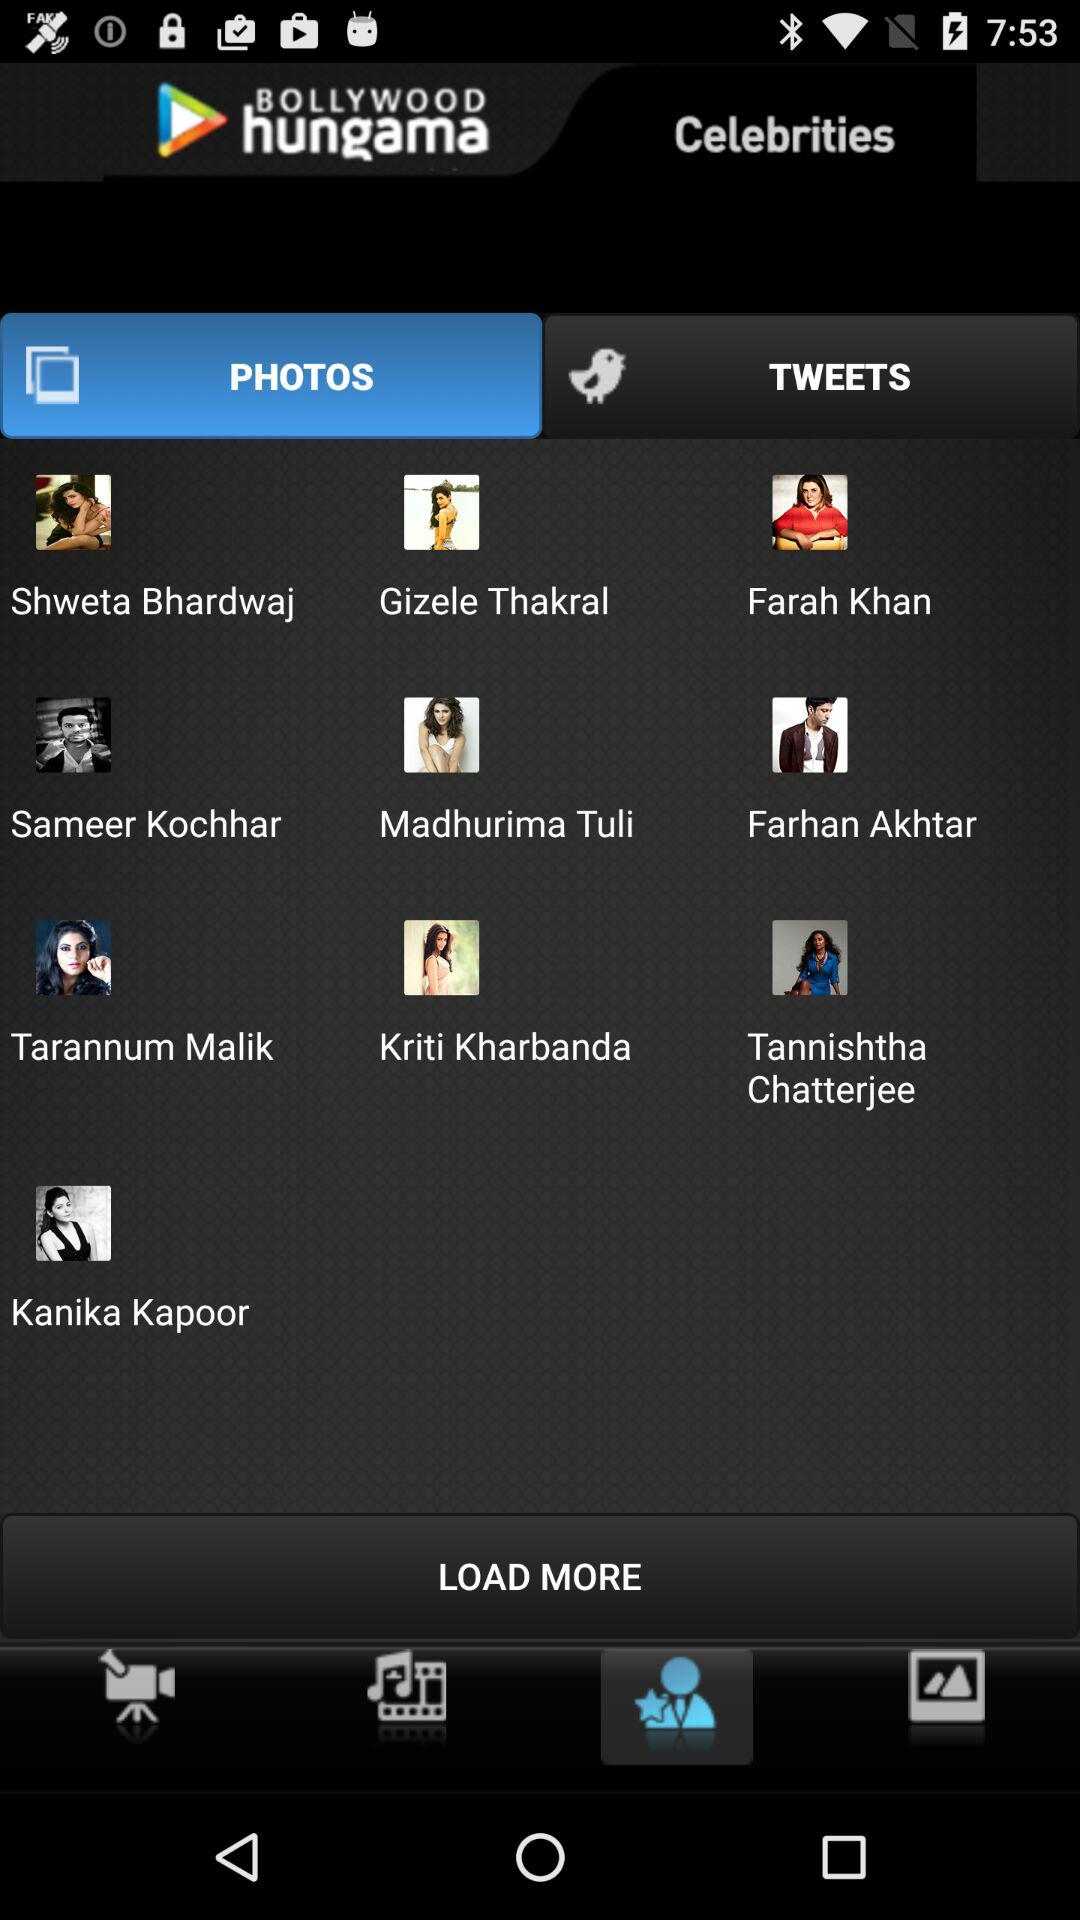Which tab is selected? The selected tab is "PHOTOS". 